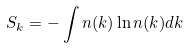<formula> <loc_0><loc_0><loc_500><loc_500>S _ { k } = - \int n ( { k } ) \ln { n ( { k } ) } d { k }</formula> 